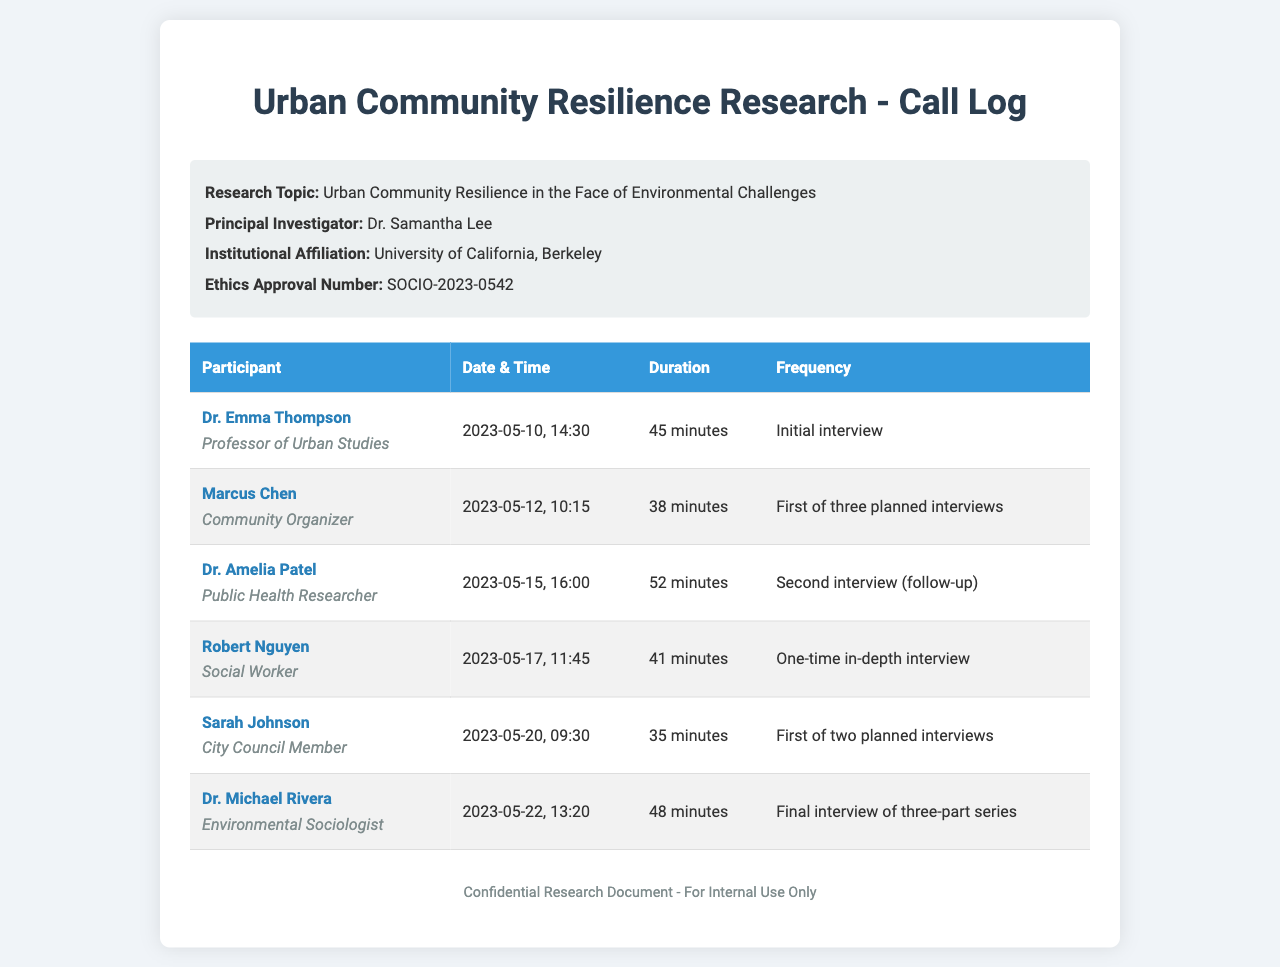What is the research topic? The research topic is explicitly stated in the document as "Urban Community Resilience in the Face of Environmental Challenges."
Answer: Urban Community Resilience in the Face of Environmental Challenges Who is the principal investigator? The principal investigator's name is provided in the document as "Dr. Samantha Lee."
Answer: Dr. Samantha Lee How long was Robert Nguyen's interview? The duration of Robert Nguyen's interview is listed as "41 minutes."
Answer: 41 minutes When did Sarah Johnson's interview take place? The date and time of Sarah Johnson's interview is specified as "2023-05-20, 09:30."
Answer: 2023-05-20, 09:30 How many planned interviews are indicated for Marcus Chen? The document states that Marcus Chen's interview is the "First of three planned interviews."
Answer: three What role does Dr. Amelia Patel have? Dr. Amelia Patel's role is identified in the document as "Public Health Researcher."
Answer: Public Health Researcher What is unique about Robert Nguyen’s interview type? The document classifies Robert Nguyen's interview as a "One-time in-depth interview," distinguishing it from others.
Answer: One-time in-depth interview How many total interviews did Dr. Michael Rivera participate in? The document records Dr. Michael Rivera's interview as the "Final interview of three-part series."
Answer: three-part series Which participant is affiliated with the City Council? The participant affiliated with the City Council is named as "Sarah Johnson."
Answer: Sarah Johnson 